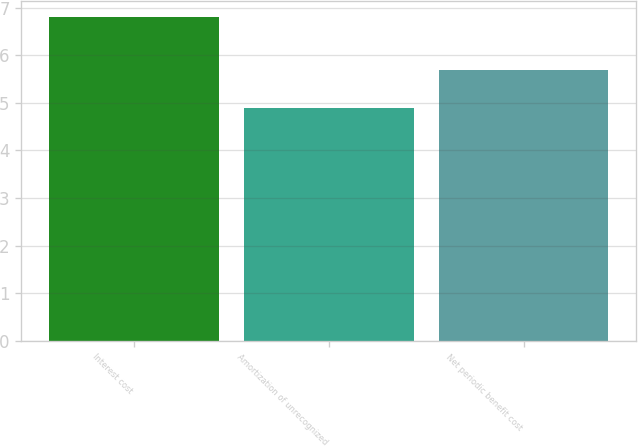<chart> <loc_0><loc_0><loc_500><loc_500><bar_chart><fcel>Interest cost<fcel>Amortization of unrecognized<fcel>Net periodic benefit cost<nl><fcel>6.8<fcel>4.9<fcel>5.7<nl></chart> 